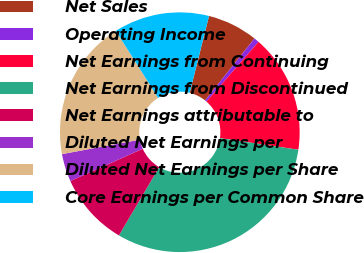Convert chart. <chart><loc_0><loc_0><loc_500><loc_500><pie_chart><fcel>Net Sales<fcel>Operating Income<fcel>Net Earnings from Continuing<fcel>Net Earnings from Discontinued<fcel>Net Earnings attributable to<fcel>Diluted Net Earnings per<fcel>Diluted Net Earnings per Share<fcel>Core Earnings per Common Share<nl><fcel>6.79%<fcel>0.7%<fcel>15.93%<fcel>31.15%<fcel>9.84%<fcel>3.75%<fcel>18.97%<fcel>12.88%<nl></chart> 